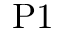Convert formula to latex. <formula><loc_0><loc_0><loc_500><loc_500>P 1</formula> 